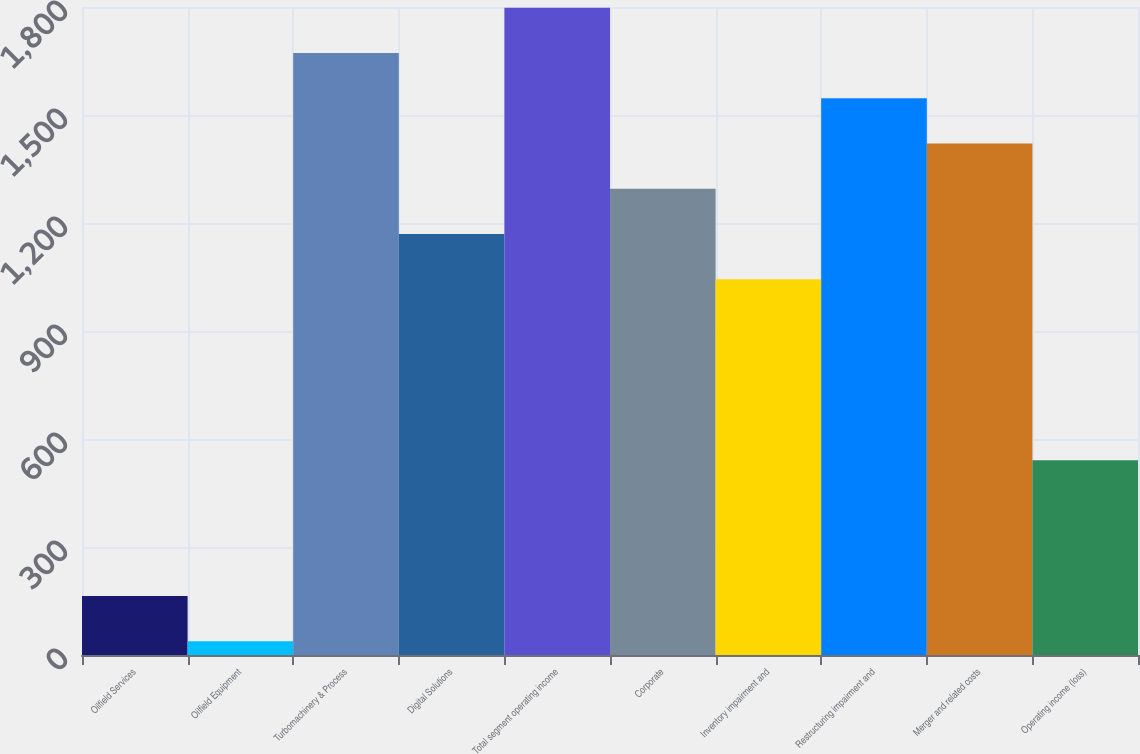Convert chart. <chart><loc_0><loc_0><loc_500><loc_500><bar_chart><fcel>Oilfield Services<fcel>Oilfield Equipment<fcel>Turbomachinery & Process<fcel>Digital Solutions<fcel>Total segment operating income<fcel>Corporate<fcel>Inventory impairment and<fcel>Restructuring impairment and<fcel>Merger and related costs<fcel>Operating income (loss)<nl><fcel>163.7<fcel>38<fcel>1672.1<fcel>1169.3<fcel>1797.8<fcel>1295<fcel>1043.6<fcel>1546.4<fcel>1420.7<fcel>540.8<nl></chart> 